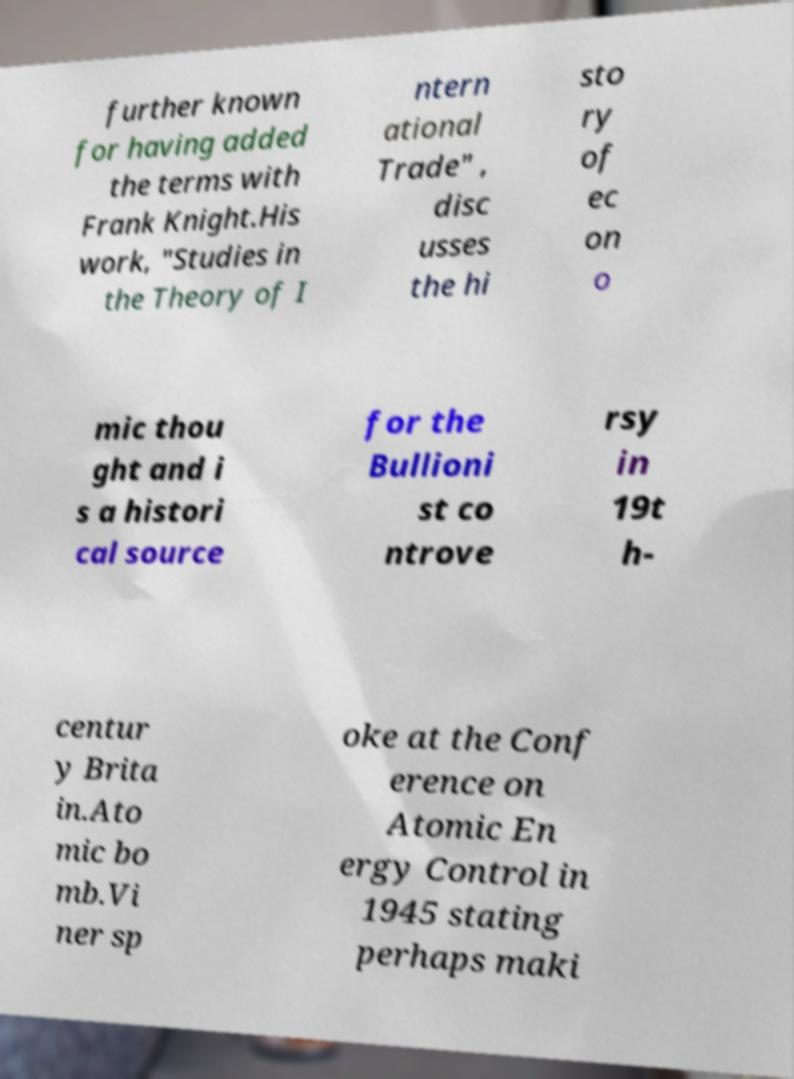For documentation purposes, I need the text within this image transcribed. Could you provide that? further known for having added the terms with Frank Knight.His work, "Studies in the Theory of I ntern ational Trade" , disc usses the hi sto ry of ec on o mic thou ght and i s a histori cal source for the Bullioni st co ntrove rsy in 19t h- centur y Brita in.Ato mic bo mb.Vi ner sp oke at the Conf erence on Atomic En ergy Control in 1945 stating perhaps maki 